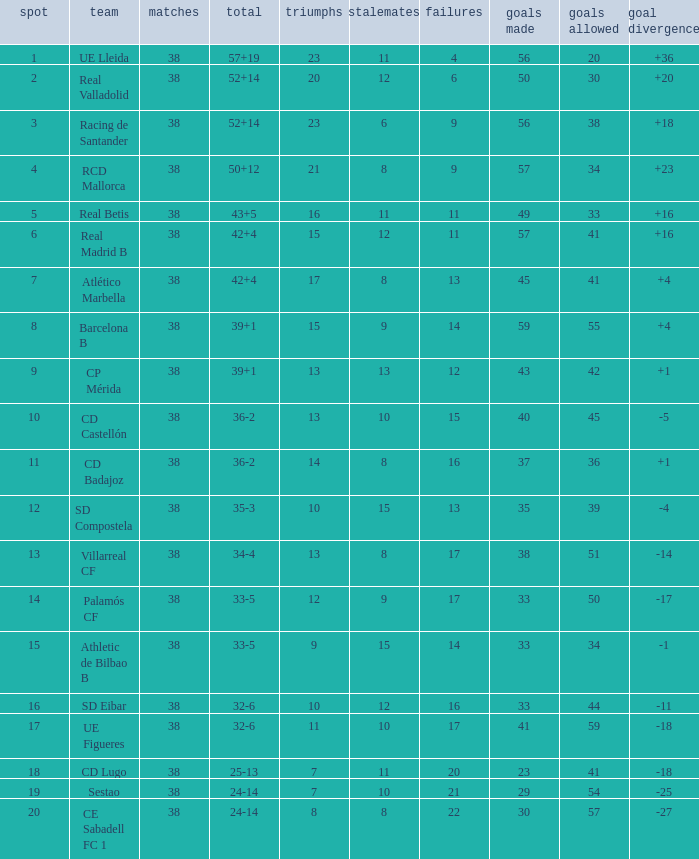What is the lowest position with 32-6 points and less then 59 goals when there are more than 38 played? None. 